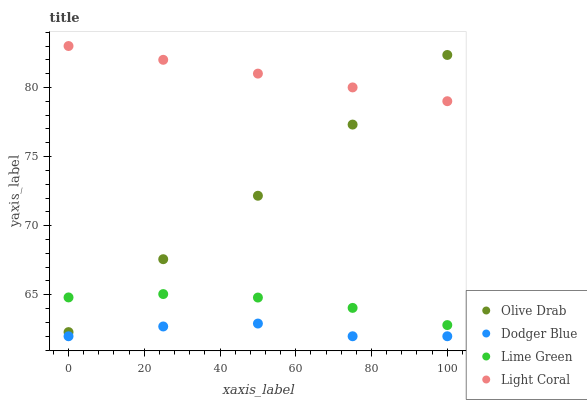Does Dodger Blue have the minimum area under the curve?
Answer yes or no. Yes. Does Light Coral have the maximum area under the curve?
Answer yes or no. Yes. Does Lime Green have the minimum area under the curve?
Answer yes or no. No. Does Lime Green have the maximum area under the curve?
Answer yes or no. No. Is Light Coral the smoothest?
Answer yes or no. Yes. Is Dodger Blue the roughest?
Answer yes or no. Yes. Is Lime Green the smoothest?
Answer yes or no. No. Is Lime Green the roughest?
Answer yes or no. No. Does Dodger Blue have the lowest value?
Answer yes or no. Yes. Does Lime Green have the lowest value?
Answer yes or no. No. Does Light Coral have the highest value?
Answer yes or no. Yes. Does Lime Green have the highest value?
Answer yes or no. No. Is Dodger Blue less than Lime Green?
Answer yes or no. Yes. Is Light Coral greater than Lime Green?
Answer yes or no. Yes. Does Olive Drab intersect Light Coral?
Answer yes or no. Yes. Is Olive Drab less than Light Coral?
Answer yes or no. No. Is Olive Drab greater than Light Coral?
Answer yes or no. No. Does Dodger Blue intersect Lime Green?
Answer yes or no. No. 